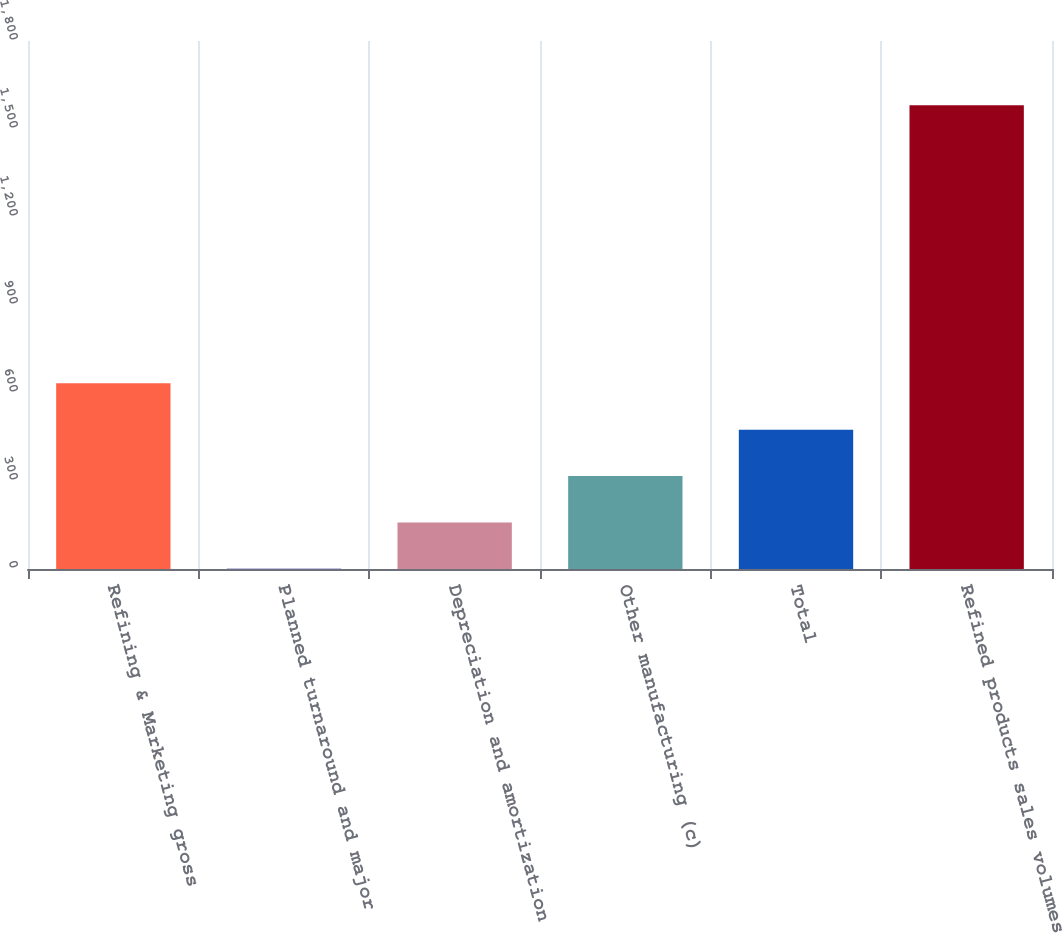Convert chart. <chart><loc_0><loc_0><loc_500><loc_500><bar_chart><fcel>Refining & Marketing gross<fcel>Planned turnaround and major<fcel>Depreciation and amortization<fcel>Other manufacturing (c)<fcel>Total<fcel>Refined products sales volumes<nl><fcel>632.86<fcel>0.78<fcel>158.8<fcel>316.82<fcel>474.84<fcel>1581<nl></chart> 